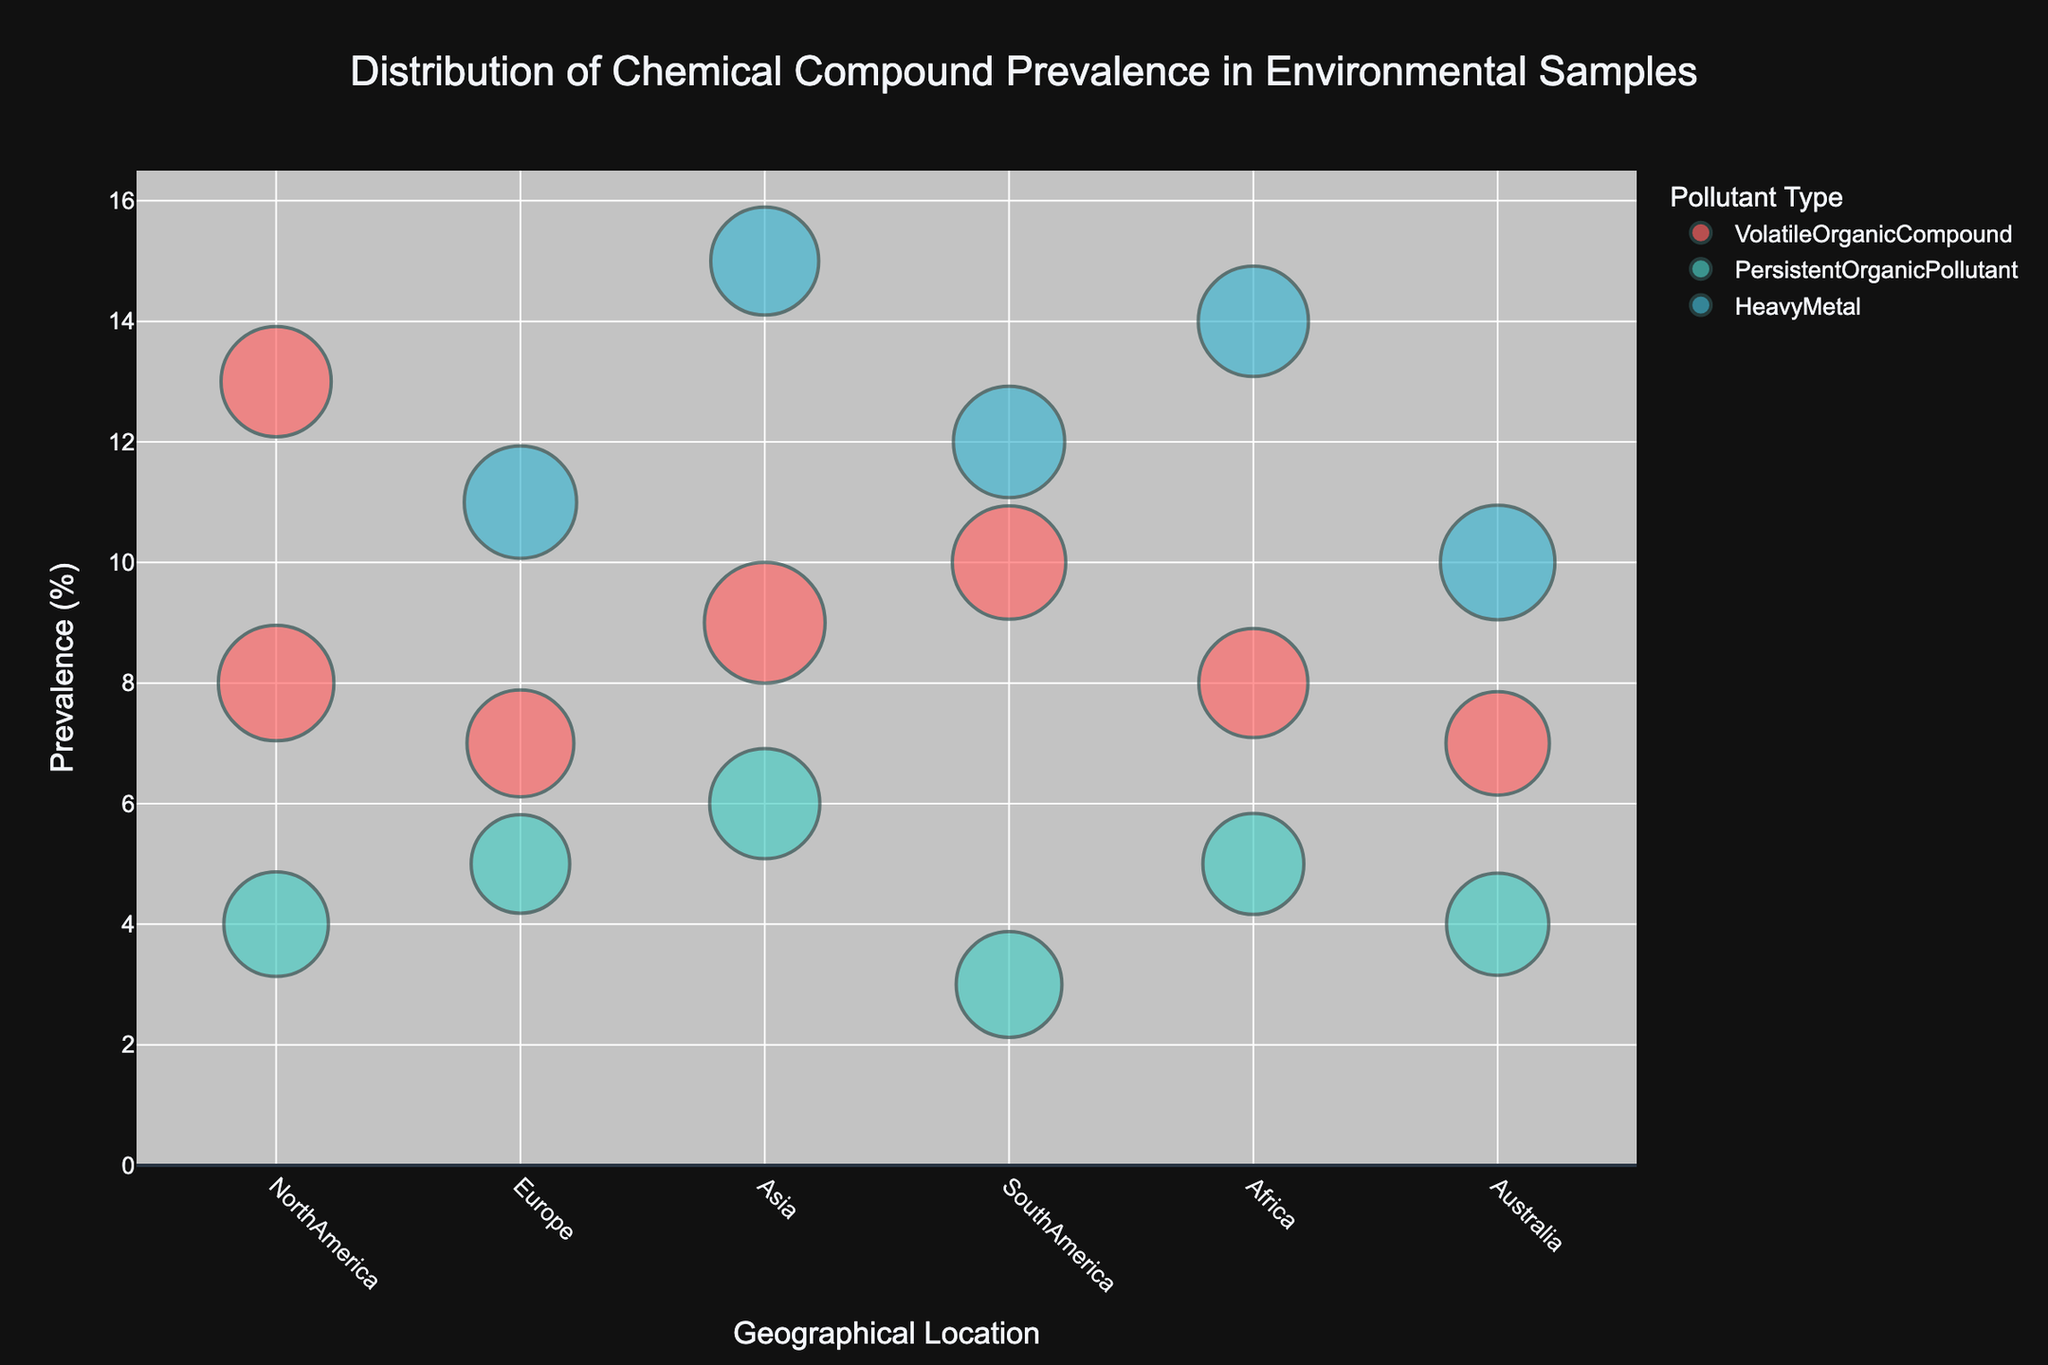Which geographical location has the highest prevalence of any chemical compound? The "Asia" bubble representing Cadmium (Heavy Metal) shows the highest prevalence at 15%.
Answer: Asia What are the Pollutant Types with the highest prevalence value in each geographical location? For North America, Benzene (13%). For Europe, Lead (11%). For Asia, Cadmium (15%). For South America, Mercury (12%). For Africa, Arsenic (14%). For Australia, Copper (10%).
Answer: North America: VolatileOrganicCompound, Europe: HeavyMetal, Asia: HeavyMetal, South America: HeavyMetal, Africa: HeavyMetal, Australia: HeavyMetal Which pollutant type is most frequently associated with the highest sample count in the chart? The bubbles for volatile organic compounds (VOC) appear to dominate the chart in terms of sample count sizes. The largest sample counts are for Xylene in Asia (60), Toluene in North America (55), and Formaldehyde in South America (53).
Answer: VolatileOrganicCompound Is there any Pollutant Type that appears in all geographical locations? By examining the color-coded bubbles, Heavy Metals are present in each geographical location: Lead (Europe), Cadmium (Asia), Mercury (South America), Arsenic (Africa), and Copper (Australia).
Answer: HeavyMetal Which chemical compounds associated with Heavy Metals have the highest prevalence in Asia and Africa, respectively? In Asia, Cadmium has the highest prevalence (15%). In Africa, Arsenic has the highest prevalence (14%).
Answer: Cadmium in Asia, Arsenic in Africa Compare the prevalence values for Persistent Organic Pollutants in Africa and South America. Which location has a higher prevalence and by how much? In Africa, Hexachlorobenzene has a prevalence of 5%. In South America, Chlordane has a prevalence of 3%. The difference in prevalence is 5% - 3% = 2%.
Answer: Africa by 2% How does the prevalence of Benzene in North America compare to that of Xylene in Asia? The prevalence of Benzene in North America is 13%, while the prevalence of Xylene in Asia is 9%. Benzene in North America has a higher prevalence by 4%.
Answer: Benzene is higher by 4% What is the combined sample count for all volatile organic compounds across all geographical locations? Summing up the sample counts for VOCs: Benzene (50), Toluene (55), Ethylbenzene (47), Xylene (60), Formaldehyde (53), Chloroform (49), Trichloroethylene (44) = 50 + 55 + 47 + 60 + 53 + 49 + 44 = 358.
Answer: 358 Which pollutant type in South America shows the lowest prevalence and what is its value? Chlordane (Persistent Organic Pollutant) in South America has the lowest prevalence, which is 3%.
Answer: Chlordane with a 3% prevalence 